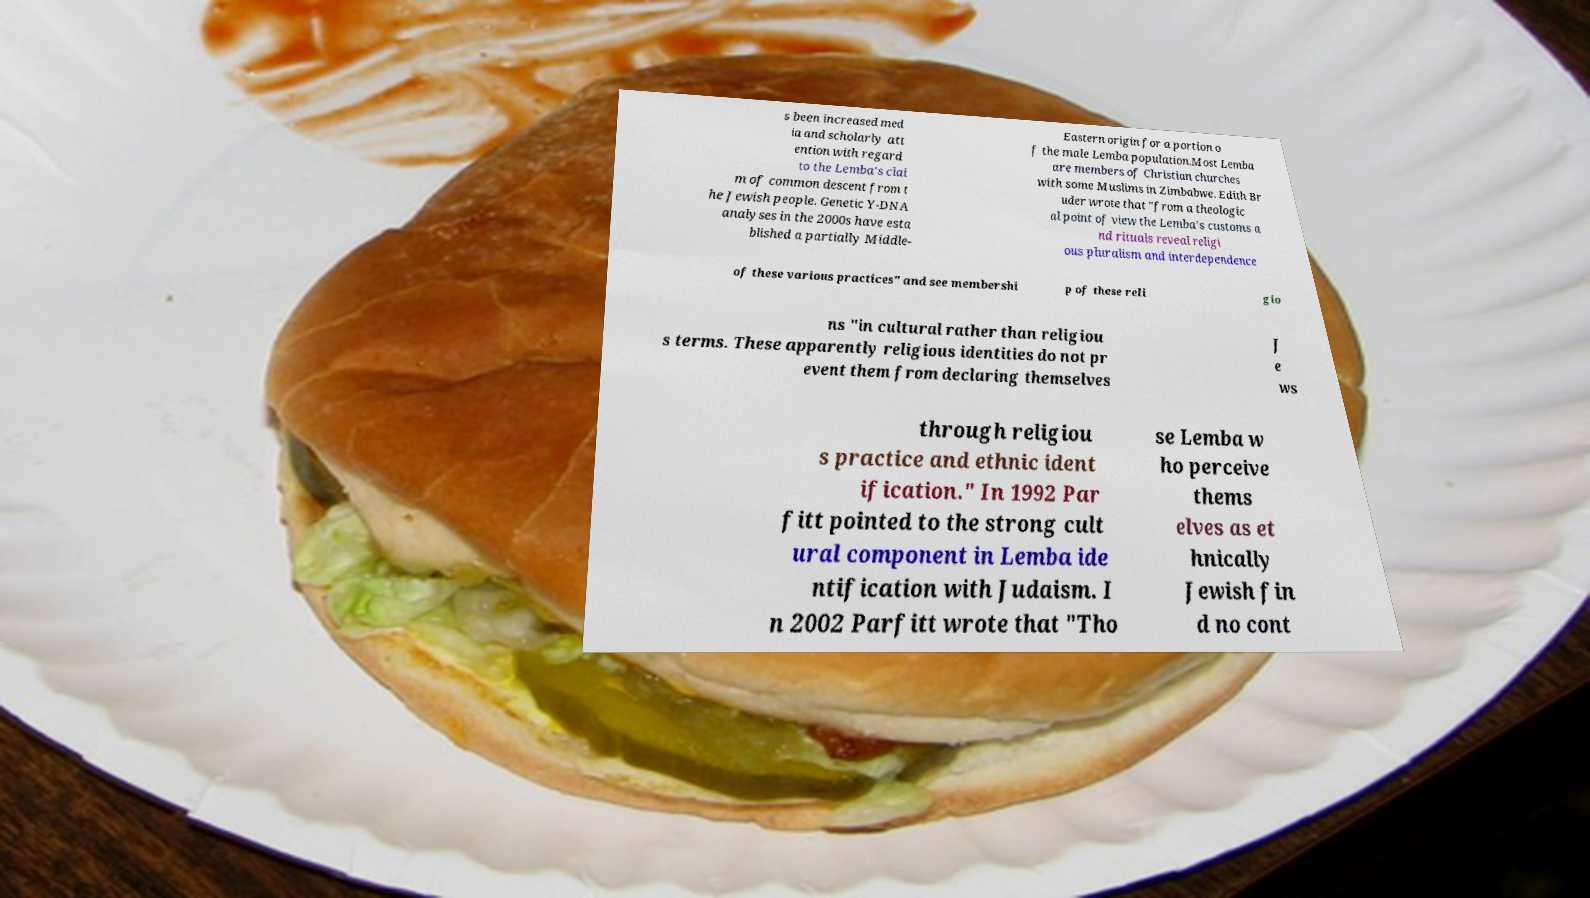Please identify and transcribe the text found in this image. s been increased med ia and scholarly att ention with regard to the Lemba's clai m of common descent from t he Jewish people. Genetic Y-DNA analyses in the 2000s have esta blished a partially Middle- Eastern origin for a portion o f the male Lemba population.Most Lemba are members of Christian churches with some Muslims in Zimbabwe. Edith Br uder wrote that "from a theologic al point of view the Lemba’s customs a nd rituals reveal religi ous pluralism and interdependence of these various practices" and see membershi p of these reli gio ns "in cultural rather than religiou s terms. These apparently religious identities do not pr event them from declaring themselves J e ws through religiou s practice and ethnic ident ification." In 1992 Par fitt pointed to the strong cult ural component in Lemba ide ntification with Judaism. I n 2002 Parfitt wrote that "Tho se Lemba w ho perceive thems elves as et hnically Jewish fin d no cont 